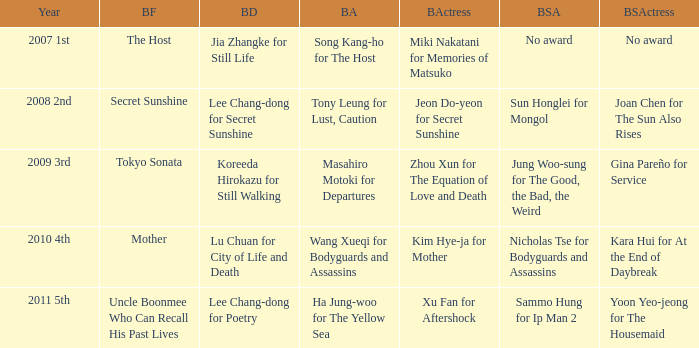Name the year for sammo hung for ip man 2 2011 5th. 